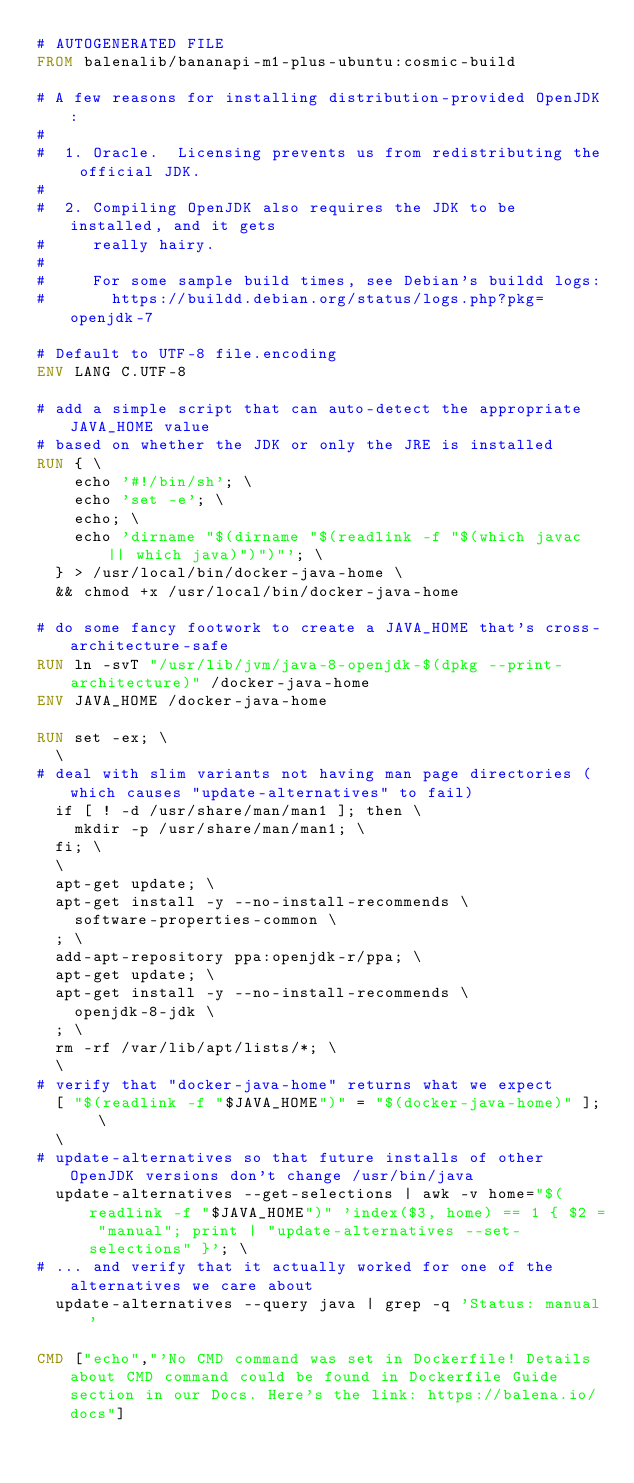Convert code to text. <code><loc_0><loc_0><loc_500><loc_500><_Dockerfile_># AUTOGENERATED FILE
FROM balenalib/bananapi-m1-plus-ubuntu:cosmic-build

# A few reasons for installing distribution-provided OpenJDK:
#
#  1. Oracle.  Licensing prevents us from redistributing the official JDK.
#
#  2. Compiling OpenJDK also requires the JDK to be installed, and it gets
#     really hairy.
#
#     For some sample build times, see Debian's buildd logs:
#       https://buildd.debian.org/status/logs.php?pkg=openjdk-7

# Default to UTF-8 file.encoding
ENV LANG C.UTF-8

# add a simple script that can auto-detect the appropriate JAVA_HOME value
# based on whether the JDK or only the JRE is installed
RUN { \
		echo '#!/bin/sh'; \
		echo 'set -e'; \
		echo; \
		echo 'dirname "$(dirname "$(readlink -f "$(which javac || which java)")")"'; \
	} > /usr/local/bin/docker-java-home \
	&& chmod +x /usr/local/bin/docker-java-home

# do some fancy footwork to create a JAVA_HOME that's cross-architecture-safe
RUN ln -svT "/usr/lib/jvm/java-8-openjdk-$(dpkg --print-architecture)" /docker-java-home
ENV JAVA_HOME /docker-java-home

RUN set -ex; \
	\
# deal with slim variants not having man page directories (which causes "update-alternatives" to fail)
	if [ ! -d /usr/share/man/man1 ]; then \
		mkdir -p /usr/share/man/man1; \
	fi; \
	\
	apt-get update; \
	apt-get install -y --no-install-recommends \
		software-properties-common \
	; \
	add-apt-repository ppa:openjdk-r/ppa; \
	apt-get update; \
	apt-get install -y --no-install-recommends \
		openjdk-8-jdk \
	; \
	rm -rf /var/lib/apt/lists/*; \
	\
# verify that "docker-java-home" returns what we expect
	[ "$(readlink -f "$JAVA_HOME")" = "$(docker-java-home)" ]; \
	\
# update-alternatives so that future installs of other OpenJDK versions don't change /usr/bin/java
	update-alternatives --get-selections | awk -v home="$(readlink -f "$JAVA_HOME")" 'index($3, home) == 1 { $2 = "manual"; print | "update-alternatives --set-selections" }'; \
# ... and verify that it actually worked for one of the alternatives we care about
	update-alternatives --query java | grep -q 'Status: manual'

CMD ["echo","'No CMD command was set in Dockerfile! Details about CMD command could be found in Dockerfile Guide section in our Docs. Here's the link: https://balena.io/docs"]</code> 